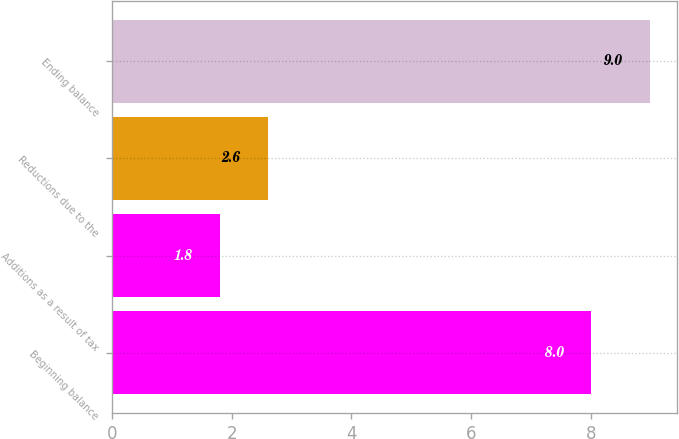Convert chart to OTSL. <chart><loc_0><loc_0><loc_500><loc_500><bar_chart><fcel>Beginning balance<fcel>Additions as a result of tax<fcel>Reductions due to the<fcel>Ending balance<nl><fcel>8<fcel>1.8<fcel>2.6<fcel>9<nl></chart> 